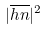<formula> <loc_0><loc_0><loc_500><loc_500>| \overline { h n } | ^ { 2 }</formula> 